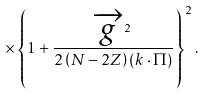Convert formula to latex. <formula><loc_0><loc_0><loc_500><loc_500>\times \left \{ 1 + \frac { \overrightarrow { g } ^ { 2 } } { 2 \left ( N - 2 Z \right ) ( k \cdot \Pi ) } \right \} ^ { 2 } .</formula> 